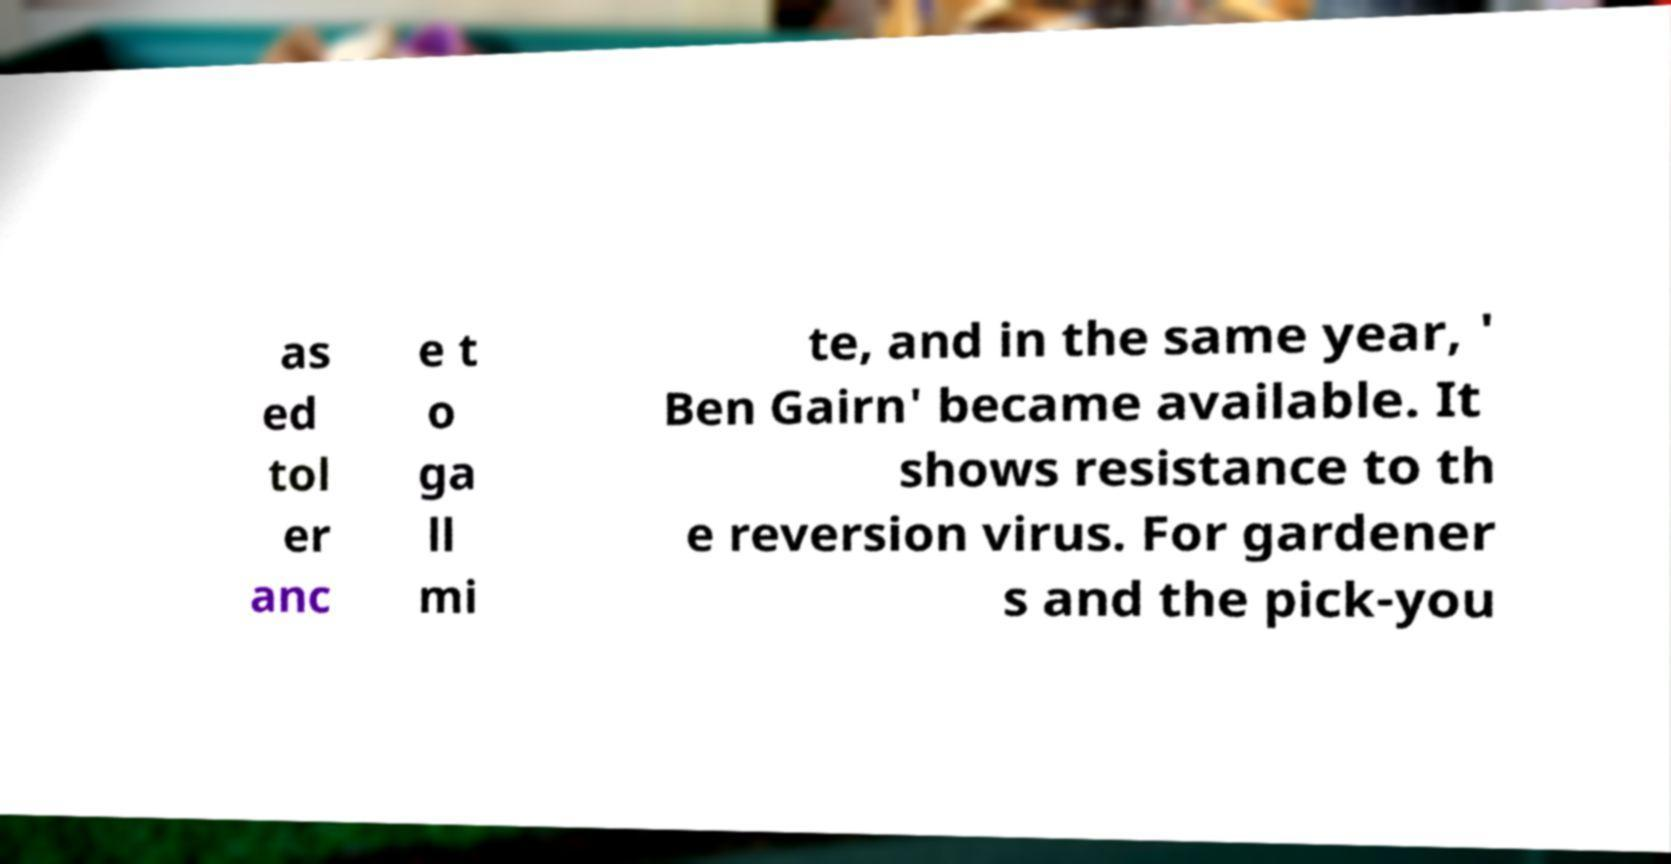Please identify and transcribe the text found in this image. as ed tol er anc e t o ga ll mi te, and in the same year, ' Ben Gairn' became available. It shows resistance to th e reversion virus. For gardener s and the pick-you 